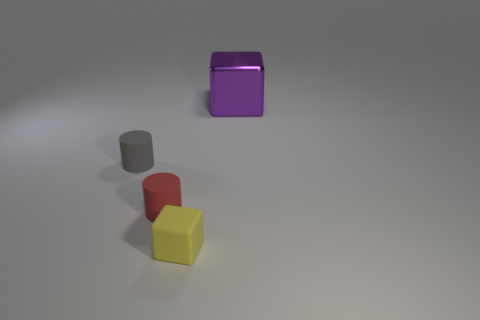Add 4 small purple matte cylinders. How many objects exist? 8 Subtract 0 gray blocks. How many objects are left? 4 Subtract all rubber cylinders. Subtract all tiny yellow rubber objects. How many objects are left? 1 Add 4 matte cubes. How many matte cubes are left? 5 Add 2 red rubber cylinders. How many red rubber cylinders exist? 3 